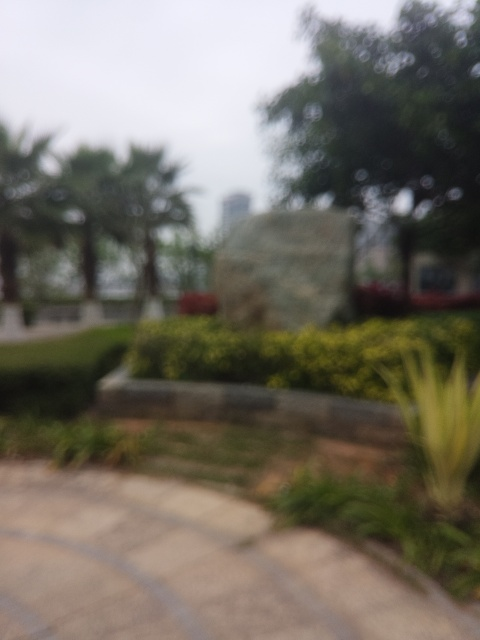Can you describe the ambiance or mood of the setting depicted in this image? Even with the blur, the image seems to portray a peaceful outdoor environment. Soft, natural light suggests it could be a cloudy day. The greenery and open space imply a park or garden-like setting, which commonly evokes a sense of tranquility. 